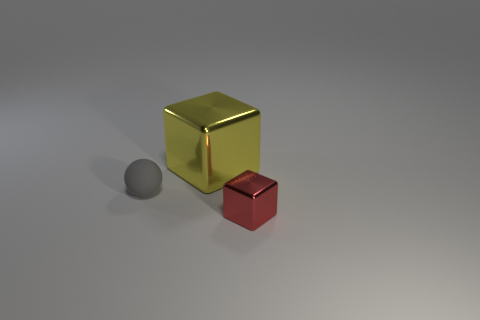Is there anything else that has the same material as the gray thing?
Your response must be concise. No. There is a small gray object; are there any objects to the right of it?
Ensure brevity in your answer.  Yes. What is the size of the object that is the same material as the tiny block?
Your response must be concise. Large. What number of large blocks are the same color as the large object?
Provide a succinct answer. 0. Are there fewer tiny red cubes that are to the left of the large yellow shiny block than red metallic objects that are to the right of the matte thing?
Your response must be concise. Yes. There is a metal object that is right of the yellow cube; how big is it?
Make the answer very short. Small. Is there a yellow thing that has the same material as the red object?
Keep it short and to the point. Yes. Are the big yellow object and the tiny red object made of the same material?
Offer a terse response. Yes. What is the color of the cube that is the same size as the rubber sphere?
Make the answer very short. Red. What number of other objects are the same shape as the yellow thing?
Make the answer very short. 1. 